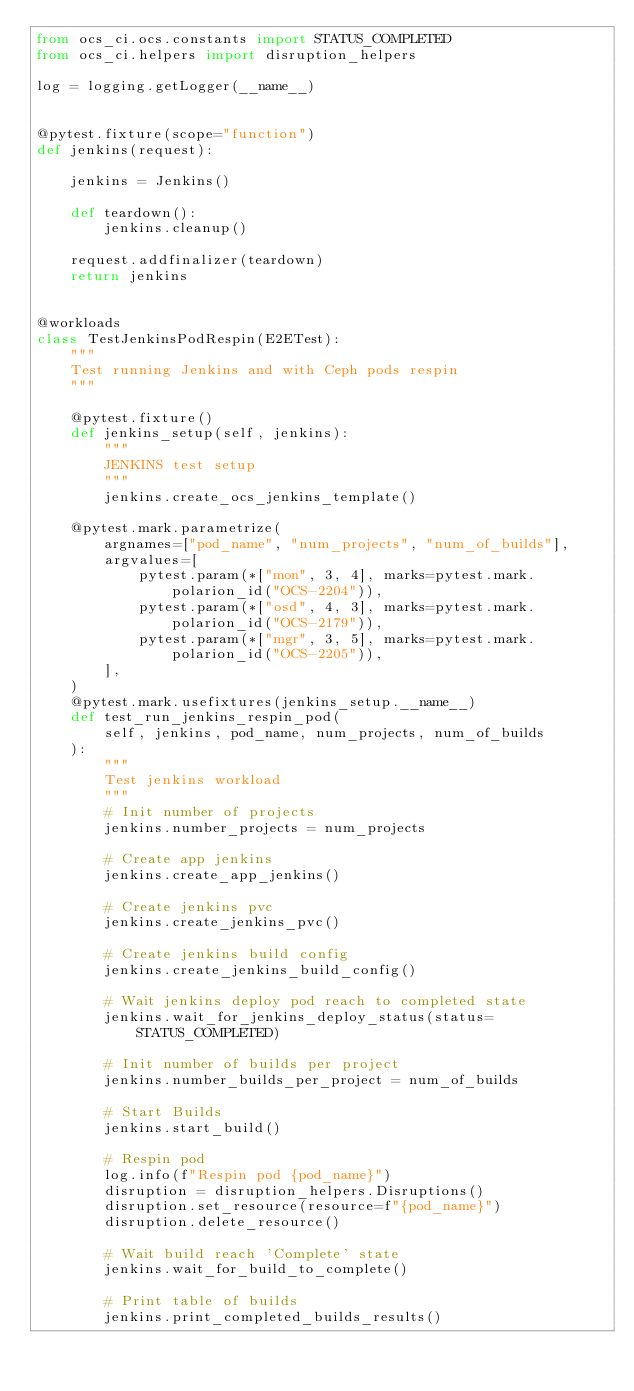Convert code to text. <code><loc_0><loc_0><loc_500><loc_500><_Python_>from ocs_ci.ocs.constants import STATUS_COMPLETED
from ocs_ci.helpers import disruption_helpers

log = logging.getLogger(__name__)


@pytest.fixture(scope="function")
def jenkins(request):

    jenkins = Jenkins()

    def teardown():
        jenkins.cleanup()

    request.addfinalizer(teardown)
    return jenkins


@workloads
class TestJenkinsPodRespin(E2ETest):
    """
    Test running Jenkins and with Ceph pods respin
    """

    @pytest.fixture()
    def jenkins_setup(self, jenkins):
        """
        JENKINS test setup
        """
        jenkins.create_ocs_jenkins_template()

    @pytest.mark.parametrize(
        argnames=["pod_name", "num_projects", "num_of_builds"],
        argvalues=[
            pytest.param(*["mon", 3, 4], marks=pytest.mark.polarion_id("OCS-2204")),
            pytest.param(*["osd", 4, 3], marks=pytest.mark.polarion_id("OCS-2179")),
            pytest.param(*["mgr", 3, 5], marks=pytest.mark.polarion_id("OCS-2205")),
        ],
    )
    @pytest.mark.usefixtures(jenkins_setup.__name__)
    def test_run_jenkins_respin_pod(
        self, jenkins, pod_name, num_projects, num_of_builds
    ):
        """
        Test jenkins workload
        """
        # Init number of projects
        jenkins.number_projects = num_projects

        # Create app jenkins
        jenkins.create_app_jenkins()

        # Create jenkins pvc
        jenkins.create_jenkins_pvc()

        # Create jenkins build config
        jenkins.create_jenkins_build_config()

        # Wait jenkins deploy pod reach to completed state
        jenkins.wait_for_jenkins_deploy_status(status=STATUS_COMPLETED)

        # Init number of builds per project
        jenkins.number_builds_per_project = num_of_builds

        # Start Builds
        jenkins.start_build()

        # Respin pod
        log.info(f"Respin pod {pod_name}")
        disruption = disruption_helpers.Disruptions()
        disruption.set_resource(resource=f"{pod_name}")
        disruption.delete_resource()

        # Wait build reach 'Complete' state
        jenkins.wait_for_build_to_complete()

        # Print table of builds
        jenkins.print_completed_builds_results()
</code> 